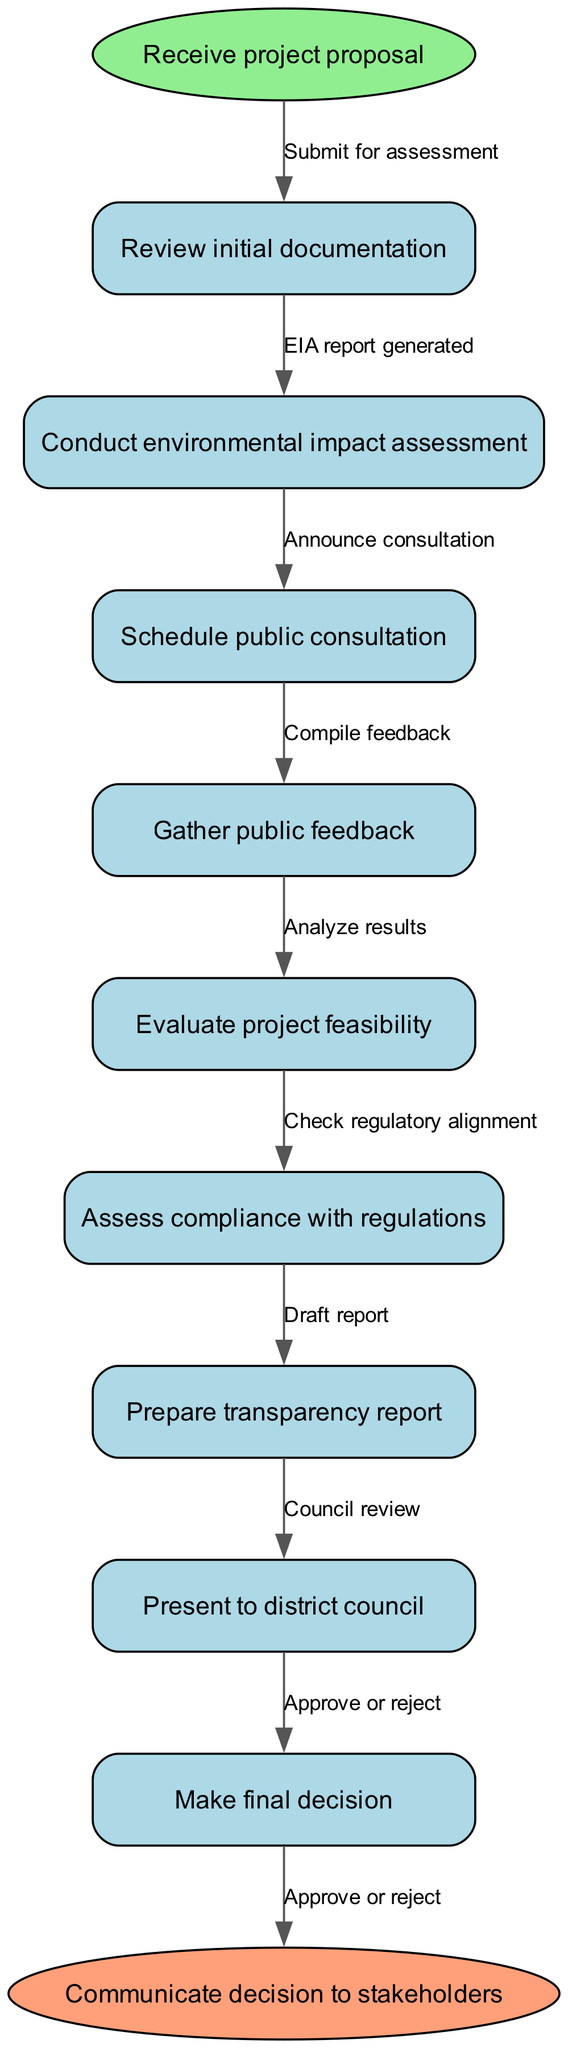What is the first node in the flowchart? The first node in the flowchart is labeled as "Receive project proposal." Since the flowchart always starts from the beginning, the first node is directly visible from the start point.
Answer: Receive project proposal How many nodes are in the flowchart? There are a total of nine nodes in the flowchart. Counting the start and end nodes along with the process nodes gives us the total number of nodes.
Answer: Nine What is the last step before the final decision is made? The last step before the final decision is labeled "Council review". To reach this conclusion, I can trace the path from the previous steps to the last node before the end node.
Answer: Council review Which node follows "Gather public feedback"? The node that follows "Gather public feedback" is "Evaluate project feasibility." This can be determined by finding the flow arrow that connects these two nodes in the sequence.
Answer: Evaluate project feasibility What edge connects the start node to the first process node? The edge that connects the start node to the first process node is labeled "Submit for assessment." This label is directly observed on the edge connecting those two points in the diagram.
Answer: Submit for assessment Explain the process after conducting the environmental impact assessment. After conducting the environmental impact assessment, the next step is to schedule a public consultation, as directed by the flowchart. This continues the sequence of actions taken following the environmental impact assessment specifically.
Answer: Schedule public consultation How many edges are there in the flowchart? There are a total of eight edges in the flowchart. By counting the connections between all nodes, including those leading to the end node, the total number of edges can be confirmed.
Answer: Eight What is required before preparing the transparency report? Before preparing the transparency report, the node "Assess compliance with regulations" must be completed. Tracing the flow from the previous node will confirm this prerequisite step directly preceding the report preparation.
Answer: Assess compliance with regulations What does the final node communicate? The final node communicates "Communicate decision to stakeholders." This is clear since it represents the end of the process where the results are disclosed to all involved parties.
Answer: Communicate decision to stakeholders 